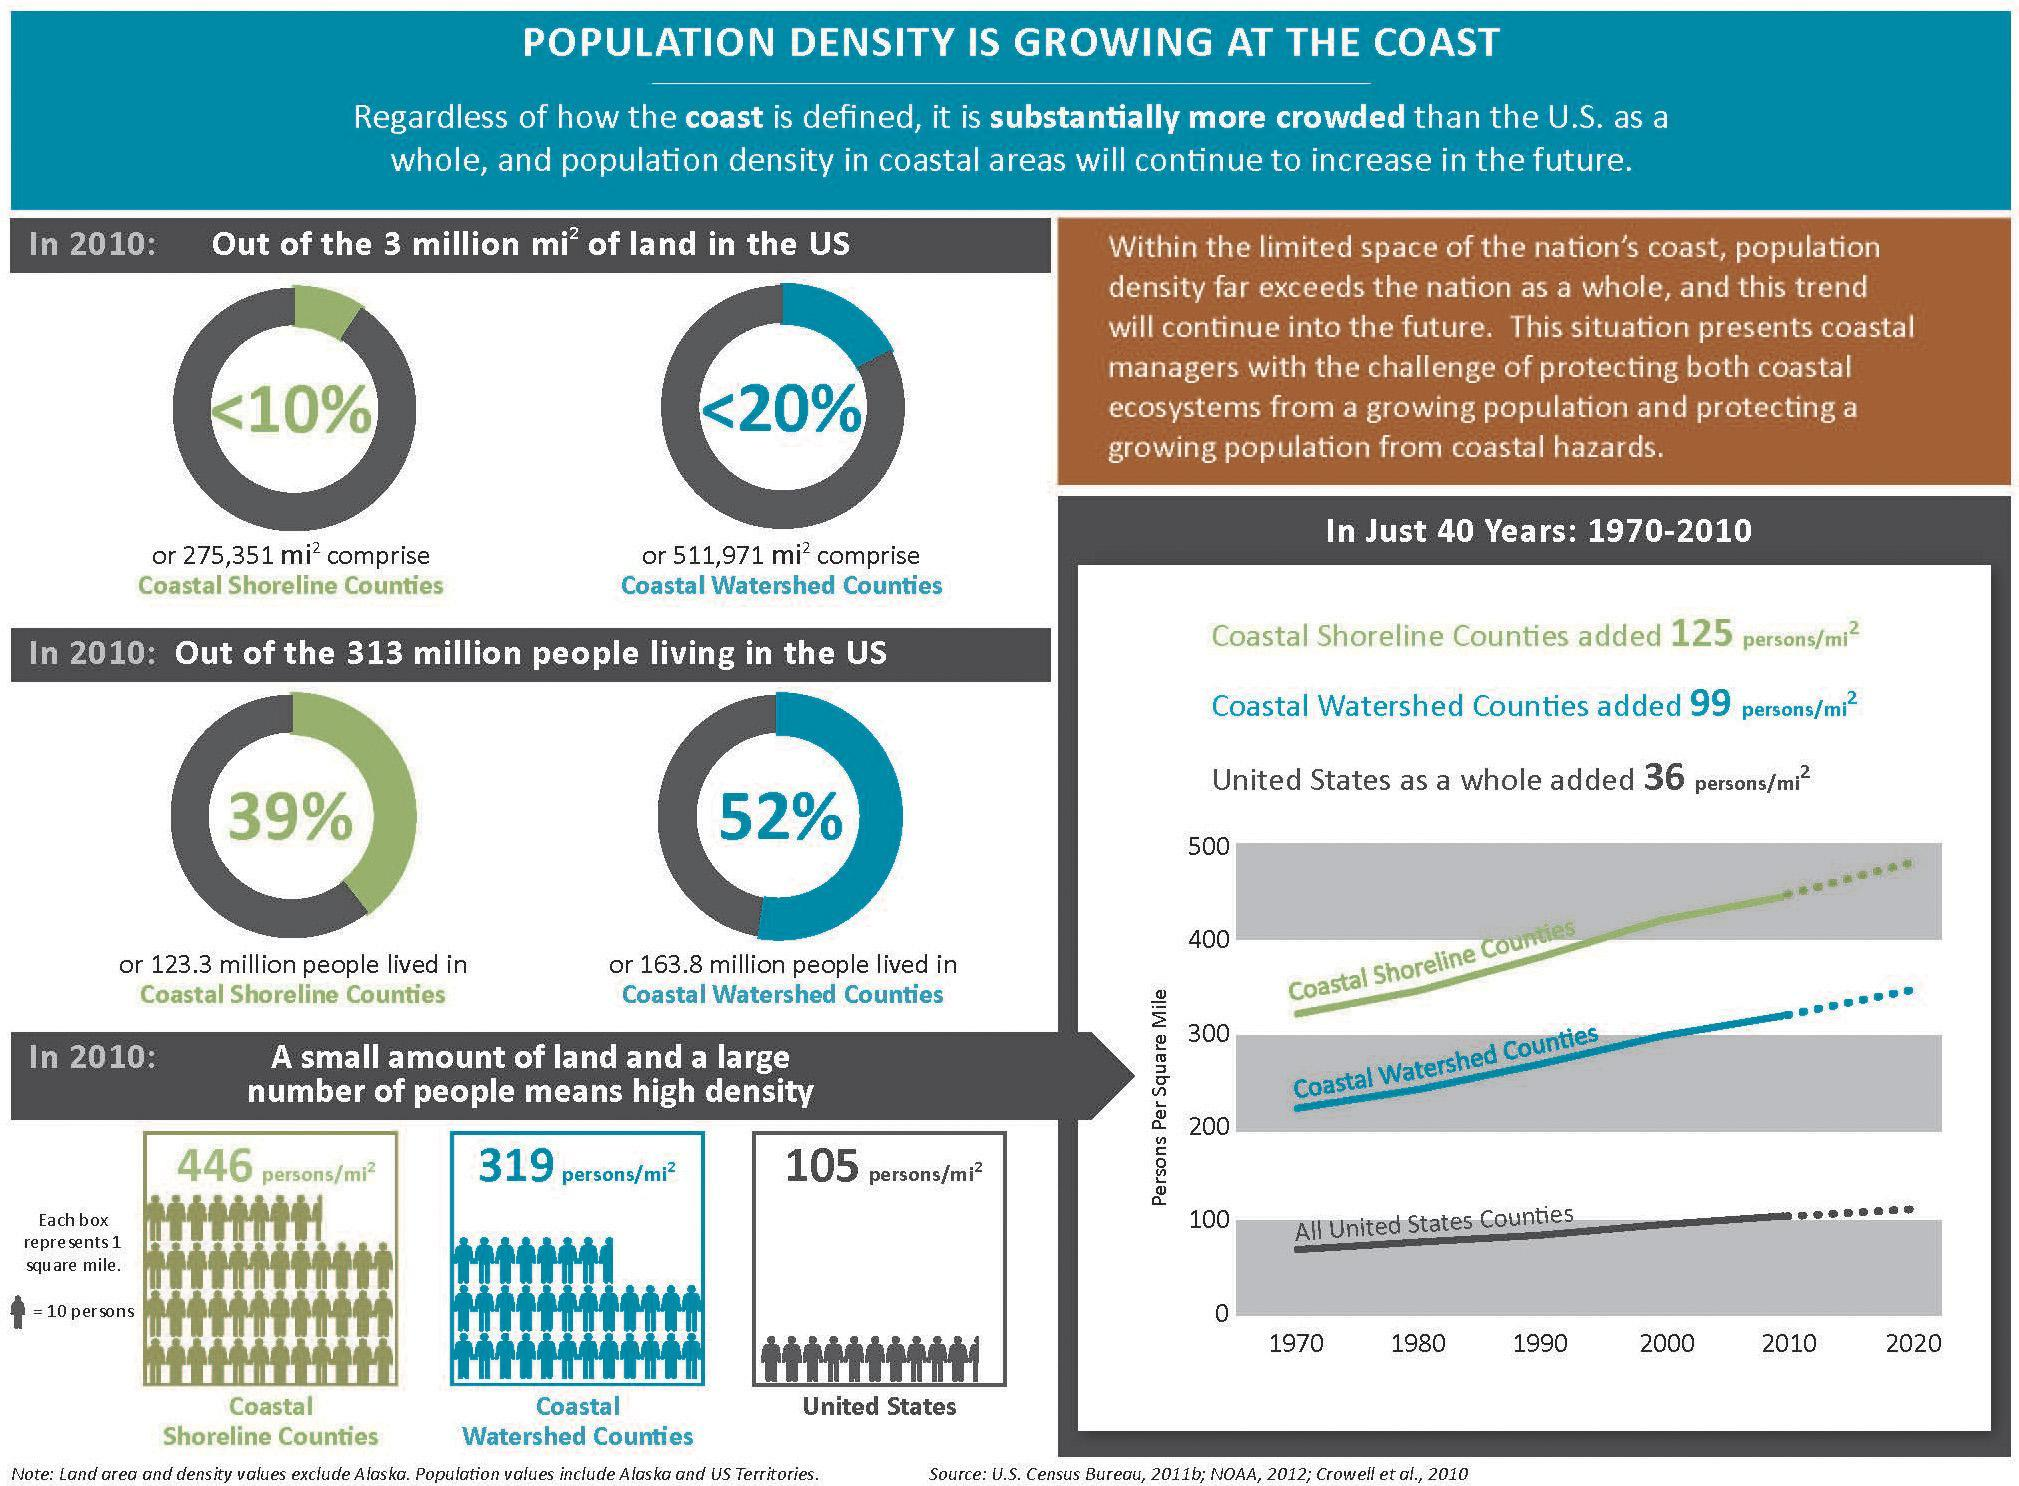What percentage of people not lived in Coastal Watershed Counties?
Answer the question with a short phrase. 48% What percentage of people not lived in Coastal Shoreline Counties? 61% 